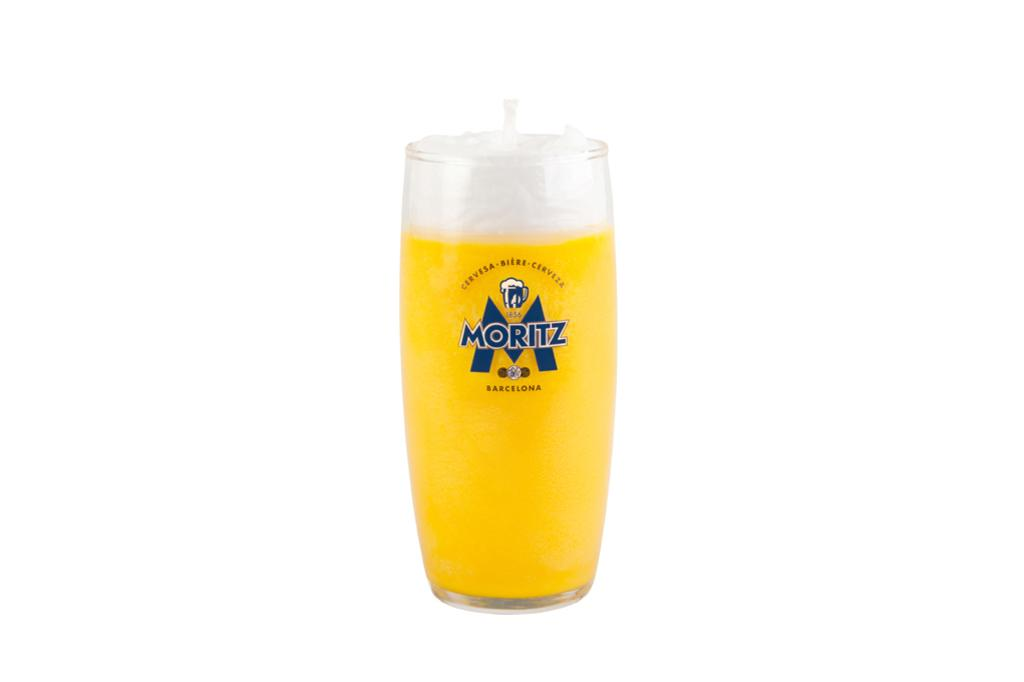<image>
Give a short and clear explanation of the subsequent image. A Moritz Cervesa Biere Cerveza cup made in 1856. 